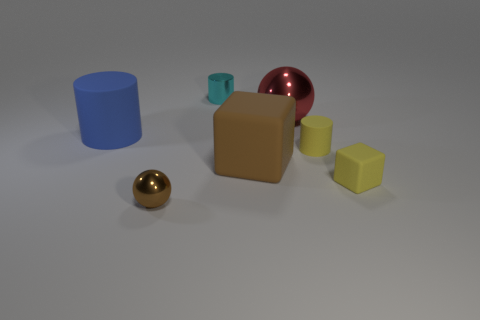Subtract all metallic cylinders. How many cylinders are left? 2 Add 1 tiny purple metallic objects. How many objects exist? 8 Add 5 cyan rubber blocks. How many cyan rubber blocks exist? 5 Subtract all cyan cylinders. How many cylinders are left? 2 Subtract 0 purple spheres. How many objects are left? 7 Subtract all spheres. How many objects are left? 5 Subtract 2 spheres. How many spheres are left? 0 Subtract all red cubes. Subtract all green balls. How many cubes are left? 2 Subtract all blue cylinders. How many gray spheres are left? 0 Subtract all tiny purple matte cubes. Subtract all tiny shiny cylinders. How many objects are left? 6 